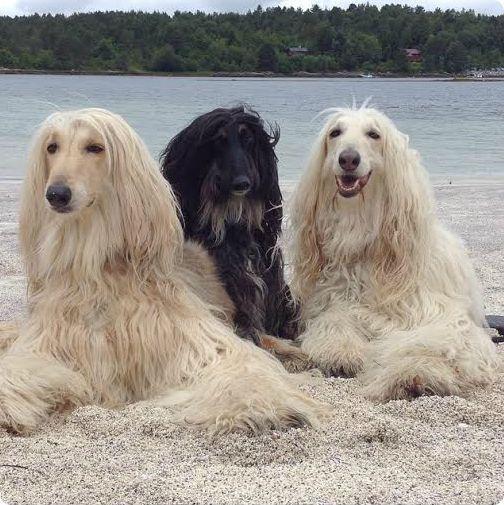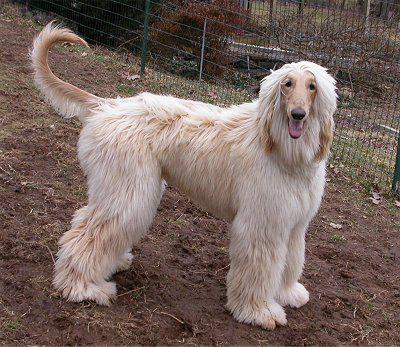The first image is the image on the left, the second image is the image on the right. Given the left and right images, does the statement "There are more dogs in the image on the left." hold true? Answer yes or no. Yes. The first image is the image on the left, the second image is the image on the right. Examine the images to the left and right. Is the description "Each image contains one afghan hound, all hounds are primarily light colored, and one hound sits upright while the other is reclining." accurate? Answer yes or no. No. 